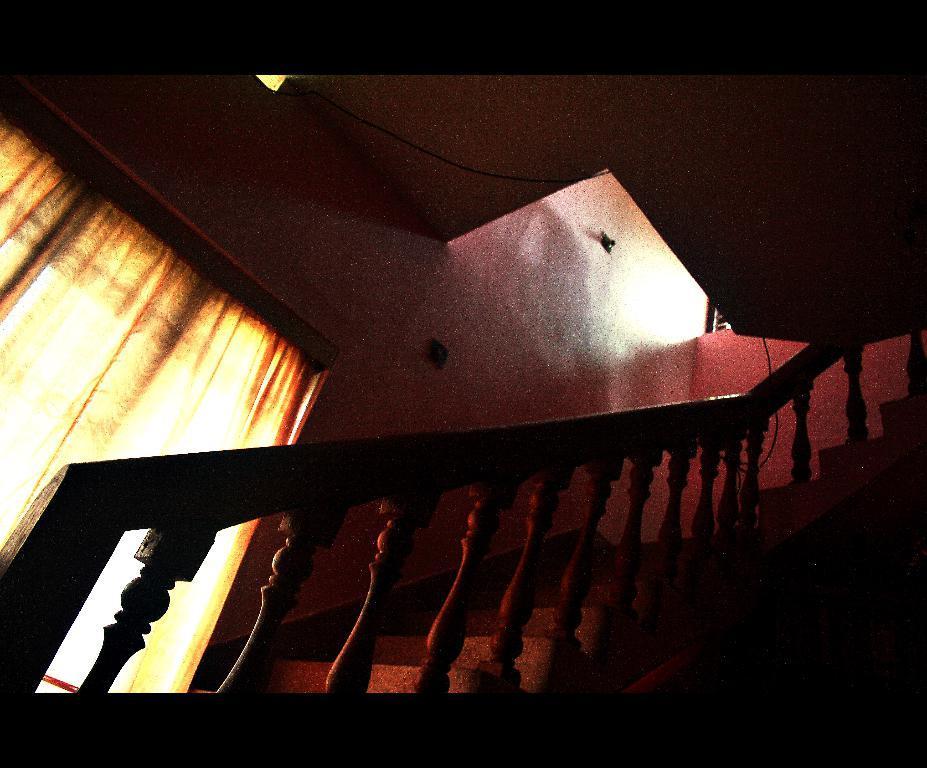In one or two sentences, can you explain what this image depicts? In this image there is a staircase. Left side there is a window, which is covered with a curtain. Background there is a wall. 